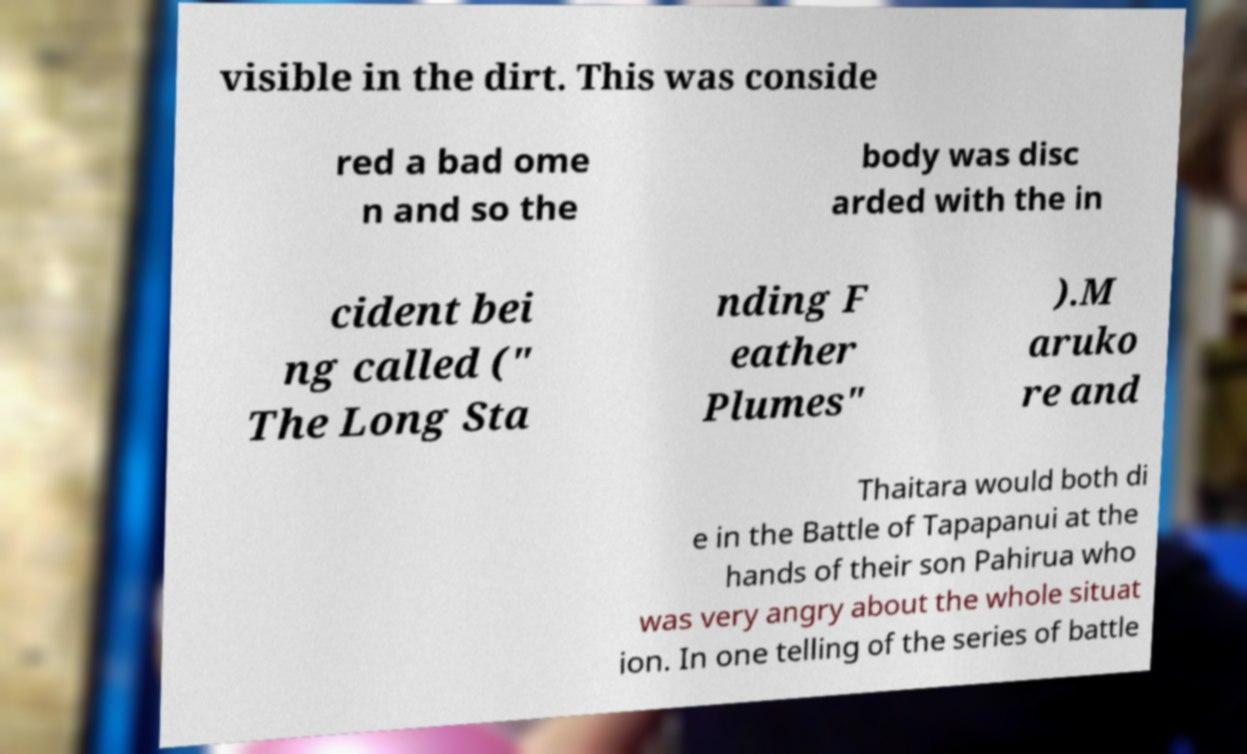Please read and relay the text visible in this image. What does it say? visible in the dirt. This was conside red a bad ome n and so the body was disc arded with the in cident bei ng called (" The Long Sta nding F eather Plumes" ).M aruko re and Thaitara would both di e in the Battle of Tapapanui at the hands of their son Pahirua who was very angry about the whole situat ion. In one telling of the series of battle 